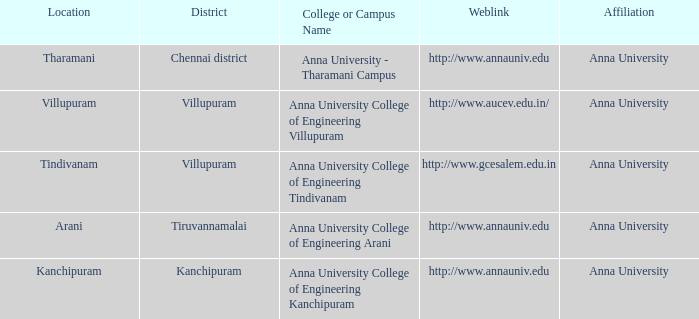What Location has a College or Campus Name of anna university - tharamani campus? Tharamani. 